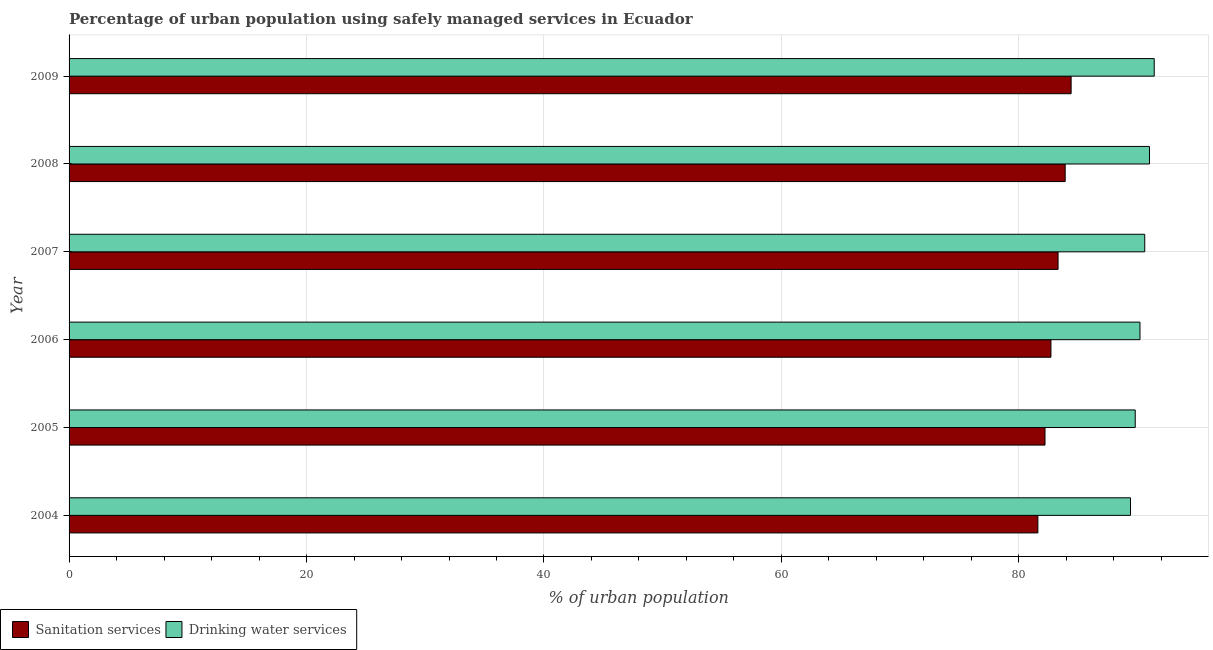How many different coloured bars are there?
Your response must be concise. 2. Are the number of bars per tick equal to the number of legend labels?
Provide a short and direct response. Yes. How many bars are there on the 3rd tick from the top?
Ensure brevity in your answer.  2. What is the percentage of urban population who used drinking water services in 2008?
Your answer should be compact. 91. Across all years, what is the maximum percentage of urban population who used drinking water services?
Give a very brief answer. 91.4. Across all years, what is the minimum percentage of urban population who used sanitation services?
Ensure brevity in your answer.  81.6. In which year was the percentage of urban population who used drinking water services minimum?
Keep it short and to the point. 2004. What is the total percentage of urban population who used drinking water services in the graph?
Your response must be concise. 542.4. What is the difference between the percentage of urban population who used drinking water services in 2007 and that in 2008?
Provide a short and direct response. -0.4. What is the difference between the percentage of urban population who used sanitation services in 2006 and the percentage of urban population who used drinking water services in 2007?
Offer a very short reply. -7.9. What is the average percentage of urban population who used sanitation services per year?
Give a very brief answer. 83.02. In the year 2005, what is the difference between the percentage of urban population who used sanitation services and percentage of urban population who used drinking water services?
Provide a short and direct response. -7.6. In how many years, is the percentage of urban population who used drinking water services greater than 24 %?
Provide a succinct answer. 6. What is the ratio of the percentage of urban population who used drinking water services in 2005 to that in 2008?
Keep it short and to the point. 0.99. Is the difference between the percentage of urban population who used sanitation services in 2007 and 2009 greater than the difference between the percentage of urban population who used drinking water services in 2007 and 2009?
Offer a very short reply. No. What is the difference between the highest and the second highest percentage of urban population who used sanitation services?
Keep it short and to the point. 0.5. What is the difference between the highest and the lowest percentage of urban population who used sanitation services?
Provide a short and direct response. 2.8. In how many years, is the percentage of urban population who used sanitation services greater than the average percentage of urban population who used sanitation services taken over all years?
Offer a terse response. 3. What does the 1st bar from the top in 2006 represents?
Your answer should be compact. Drinking water services. What does the 2nd bar from the bottom in 2004 represents?
Your answer should be compact. Drinking water services. How many bars are there?
Provide a succinct answer. 12. Are all the bars in the graph horizontal?
Keep it short and to the point. Yes. How many years are there in the graph?
Your answer should be compact. 6. What is the difference between two consecutive major ticks on the X-axis?
Provide a succinct answer. 20. Does the graph contain any zero values?
Give a very brief answer. No. Does the graph contain grids?
Your answer should be compact. Yes. Where does the legend appear in the graph?
Your answer should be very brief. Bottom left. What is the title of the graph?
Keep it short and to the point. Percentage of urban population using safely managed services in Ecuador. Does "Banks" appear as one of the legend labels in the graph?
Give a very brief answer. No. What is the label or title of the X-axis?
Offer a terse response. % of urban population. What is the % of urban population in Sanitation services in 2004?
Offer a very short reply. 81.6. What is the % of urban population in Drinking water services in 2004?
Your answer should be very brief. 89.4. What is the % of urban population of Sanitation services in 2005?
Ensure brevity in your answer.  82.2. What is the % of urban population in Drinking water services in 2005?
Give a very brief answer. 89.8. What is the % of urban population in Sanitation services in 2006?
Keep it short and to the point. 82.7. What is the % of urban population in Drinking water services in 2006?
Your answer should be very brief. 90.2. What is the % of urban population of Sanitation services in 2007?
Provide a short and direct response. 83.3. What is the % of urban population in Drinking water services in 2007?
Offer a terse response. 90.6. What is the % of urban population in Sanitation services in 2008?
Your response must be concise. 83.9. What is the % of urban population in Drinking water services in 2008?
Ensure brevity in your answer.  91. What is the % of urban population in Sanitation services in 2009?
Make the answer very short. 84.4. What is the % of urban population in Drinking water services in 2009?
Your answer should be very brief. 91.4. Across all years, what is the maximum % of urban population in Sanitation services?
Provide a succinct answer. 84.4. Across all years, what is the maximum % of urban population of Drinking water services?
Ensure brevity in your answer.  91.4. Across all years, what is the minimum % of urban population of Sanitation services?
Your answer should be compact. 81.6. Across all years, what is the minimum % of urban population in Drinking water services?
Your answer should be very brief. 89.4. What is the total % of urban population in Sanitation services in the graph?
Ensure brevity in your answer.  498.1. What is the total % of urban population in Drinking water services in the graph?
Ensure brevity in your answer.  542.4. What is the difference between the % of urban population in Drinking water services in 2004 and that in 2005?
Your answer should be very brief. -0.4. What is the difference between the % of urban population of Drinking water services in 2004 and that in 2006?
Make the answer very short. -0.8. What is the difference between the % of urban population in Sanitation services in 2004 and that in 2007?
Ensure brevity in your answer.  -1.7. What is the difference between the % of urban population of Drinking water services in 2004 and that in 2007?
Offer a very short reply. -1.2. What is the difference between the % of urban population of Sanitation services in 2004 and that in 2008?
Your response must be concise. -2.3. What is the difference between the % of urban population of Drinking water services in 2004 and that in 2009?
Provide a succinct answer. -2. What is the difference between the % of urban population in Drinking water services in 2005 and that in 2006?
Your answer should be compact. -0.4. What is the difference between the % of urban population of Drinking water services in 2005 and that in 2007?
Make the answer very short. -0.8. What is the difference between the % of urban population in Sanitation services in 2005 and that in 2008?
Give a very brief answer. -1.7. What is the difference between the % of urban population of Drinking water services in 2005 and that in 2008?
Your response must be concise. -1.2. What is the difference between the % of urban population in Drinking water services in 2006 and that in 2007?
Ensure brevity in your answer.  -0.4. What is the difference between the % of urban population of Sanitation services in 2006 and that in 2008?
Provide a short and direct response. -1.2. What is the difference between the % of urban population in Drinking water services in 2006 and that in 2008?
Your answer should be very brief. -0.8. What is the difference between the % of urban population in Sanitation services in 2006 and that in 2009?
Offer a terse response. -1.7. What is the difference between the % of urban population of Sanitation services in 2007 and that in 2008?
Your answer should be very brief. -0.6. What is the difference between the % of urban population in Drinking water services in 2007 and that in 2008?
Your answer should be very brief. -0.4. What is the difference between the % of urban population of Drinking water services in 2007 and that in 2009?
Your answer should be compact. -0.8. What is the difference between the % of urban population in Sanitation services in 2008 and that in 2009?
Offer a very short reply. -0.5. What is the difference between the % of urban population in Sanitation services in 2004 and the % of urban population in Drinking water services in 2005?
Provide a short and direct response. -8.2. What is the difference between the % of urban population of Sanitation services in 2004 and the % of urban population of Drinking water services in 2007?
Keep it short and to the point. -9. What is the difference between the % of urban population in Sanitation services in 2004 and the % of urban population in Drinking water services in 2008?
Your response must be concise. -9.4. What is the difference between the % of urban population in Sanitation services in 2004 and the % of urban population in Drinking water services in 2009?
Provide a succinct answer. -9.8. What is the difference between the % of urban population of Sanitation services in 2005 and the % of urban population of Drinking water services in 2006?
Provide a succinct answer. -8. What is the difference between the % of urban population of Sanitation services in 2005 and the % of urban population of Drinking water services in 2007?
Provide a succinct answer. -8.4. What is the difference between the % of urban population in Sanitation services in 2005 and the % of urban population in Drinking water services in 2008?
Your response must be concise. -8.8. What is the difference between the % of urban population in Sanitation services in 2005 and the % of urban population in Drinking water services in 2009?
Give a very brief answer. -9.2. What is the difference between the % of urban population of Sanitation services in 2006 and the % of urban population of Drinking water services in 2007?
Ensure brevity in your answer.  -7.9. What is the average % of urban population of Sanitation services per year?
Your response must be concise. 83.02. What is the average % of urban population in Drinking water services per year?
Provide a succinct answer. 90.4. In the year 2008, what is the difference between the % of urban population of Sanitation services and % of urban population of Drinking water services?
Your answer should be compact. -7.1. What is the ratio of the % of urban population of Sanitation services in 2004 to that in 2005?
Give a very brief answer. 0.99. What is the ratio of the % of urban population of Drinking water services in 2004 to that in 2005?
Offer a very short reply. 1. What is the ratio of the % of urban population in Sanitation services in 2004 to that in 2006?
Provide a succinct answer. 0.99. What is the ratio of the % of urban population of Sanitation services in 2004 to that in 2007?
Provide a short and direct response. 0.98. What is the ratio of the % of urban population of Drinking water services in 2004 to that in 2007?
Provide a short and direct response. 0.99. What is the ratio of the % of urban population in Sanitation services in 2004 to that in 2008?
Your answer should be compact. 0.97. What is the ratio of the % of urban population in Drinking water services in 2004 to that in 2008?
Offer a very short reply. 0.98. What is the ratio of the % of urban population of Sanitation services in 2004 to that in 2009?
Offer a very short reply. 0.97. What is the ratio of the % of urban population of Drinking water services in 2004 to that in 2009?
Provide a succinct answer. 0.98. What is the ratio of the % of urban population of Sanitation services in 2005 to that in 2007?
Offer a very short reply. 0.99. What is the ratio of the % of urban population of Drinking water services in 2005 to that in 2007?
Your answer should be compact. 0.99. What is the ratio of the % of urban population in Sanitation services in 2005 to that in 2008?
Give a very brief answer. 0.98. What is the ratio of the % of urban population of Sanitation services in 2005 to that in 2009?
Your answer should be compact. 0.97. What is the ratio of the % of urban population in Drinking water services in 2005 to that in 2009?
Make the answer very short. 0.98. What is the ratio of the % of urban population of Sanitation services in 2006 to that in 2007?
Your response must be concise. 0.99. What is the ratio of the % of urban population of Drinking water services in 2006 to that in 2007?
Provide a short and direct response. 1. What is the ratio of the % of urban population in Sanitation services in 2006 to that in 2008?
Your answer should be compact. 0.99. What is the ratio of the % of urban population of Drinking water services in 2006 to that in 2008?
Ensure brevity in your answer.  0.99. What is the ratio of the % of urban population of Sanitation services in 2006 to that in 2009?
Provide a succinct answer. 0.98. What is the ratio of the % of urban population in Drinking water services in 2006 to that in 2009?
Provide a short and direct response. 0.99. What is the ratio of the % of urban population of Sanitation services in 2007 to that in 2008?
Make the answer very short. 0.99. What is the ratio of the % of urban population of Sanitation services in 2007 to that in 2009?
Ensure brevity in your answer.  0.99. What is the ratio of the % of urban population of Drinking water services in 2007 to that in 2009?
Keep it short and to the point. 0.99. What is the ratio of the % of urban population in Sanitation services in 2008 to that in 2009?
Provide a succinct answer. 0.99. What is the ratio of the % of urban population of Drinking water services in 2008 to that in 2009?
Your answer should be very brief. 1. What is the difference between the highest and the second highest % of urban population of Sanitation services?
Provide a succinct answer. 0.5. What is the difference between the highest and the lowest % of urban population of Drinking water services?
Provide a short and direct response. 2. 